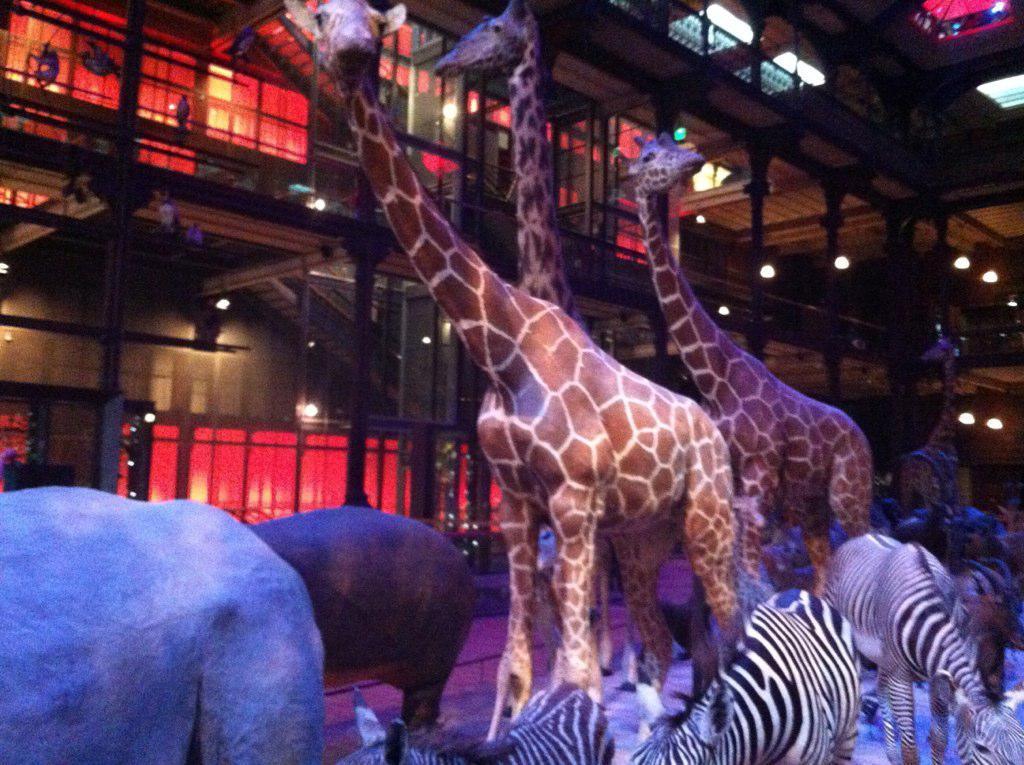How would you summarize this image in a sentence or two? This is an inside view of a building. In this image, we can see giraffes, zebras and animals are on the floor. In the background, we can see wall, poles, lights, glass objects, few things and ceiling. 